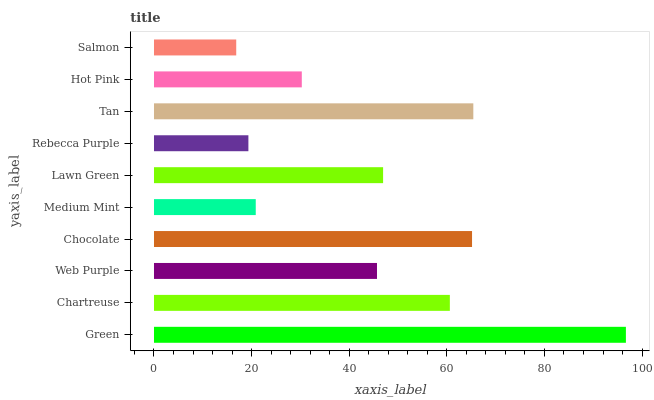Is Salmon the minimum?
Answer yes or no. Yes. Is Green the maximum?
Answer yes or no. Yes. Is Chartreuse the minimum?
Answer yes or no. No. Is Chartreuse the maximum?
Answer yes or no. No. Is Green greater than Chartreuse?
Answer yes or no. Yes. Is Chartreuse less than Green?
Answer yes or no. Yes. Is Chartreuse greater than Green?
Answer yes or no. No. Is Green less than Chartreuse?
Answer yes or no. No. Is Lawn Green the high median?
Answer yes or no. Yes. Is Web Purple the low median?
Answer yes or no. Yes. Is Chocolate the high median?
Answer yes or no. No. Is Hot Pink the low median?
Answer yes or no. No. 